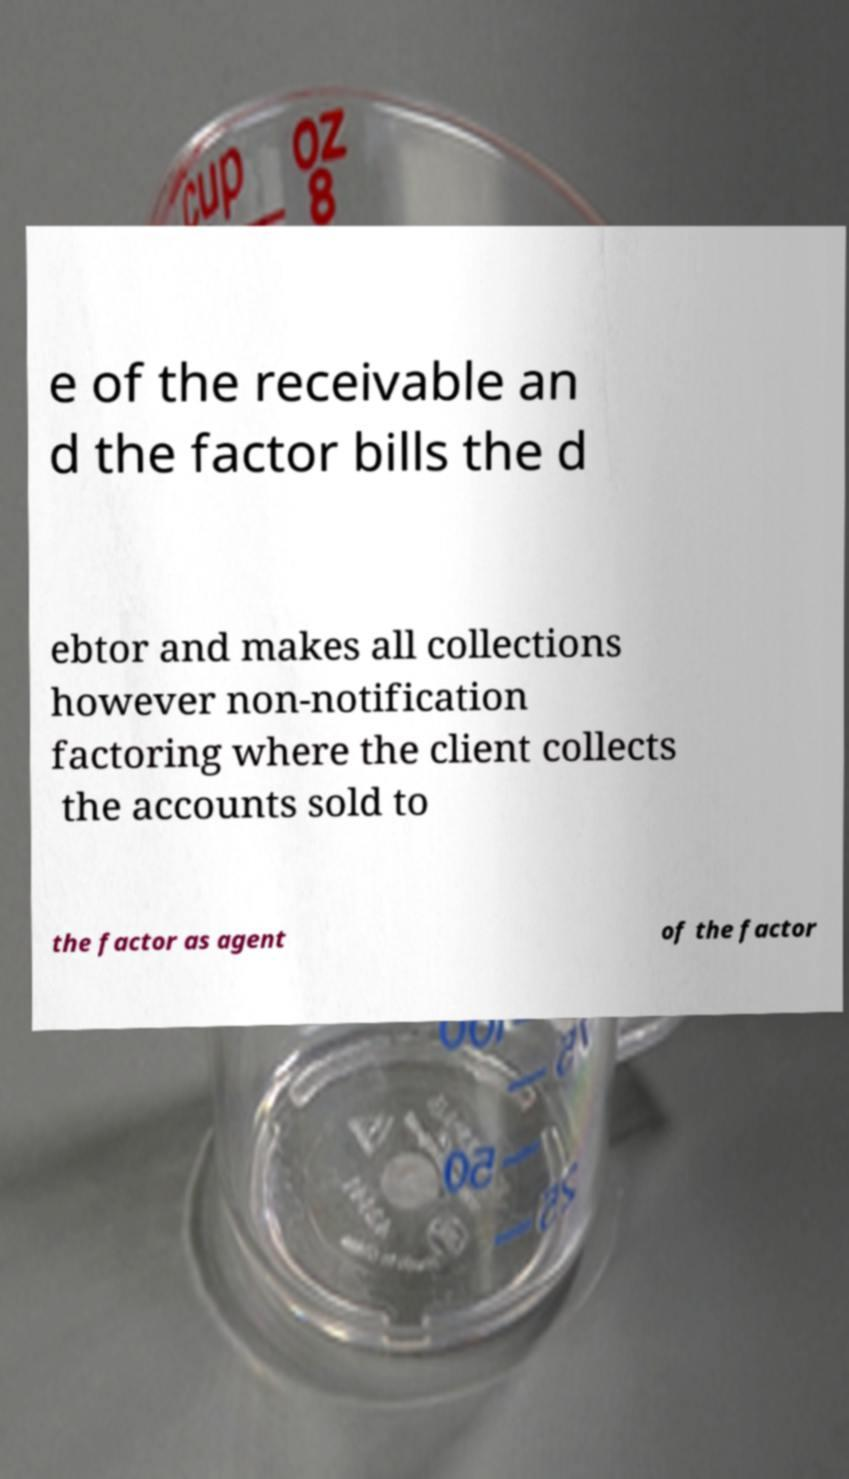Please read and relay the text visible in this image. What does it say? e of the receivable an d the factor bills the d ebtor and makes all collections however non-notification factoring where the client collects the accounts sold to the factor as agent of the factor 